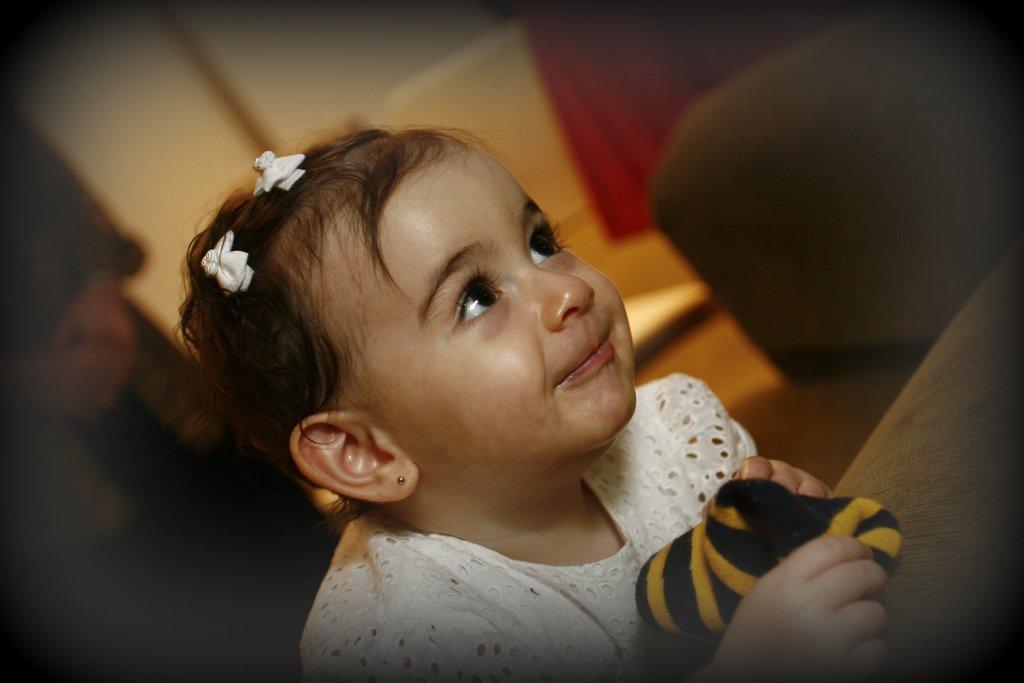Could you give a brief overview of what you see in this image? In the picture I can see a child wearing a white color dress is holding a black and yellow color socks and smiling. The surroundings of the image are slightly blurred and which is dark. 